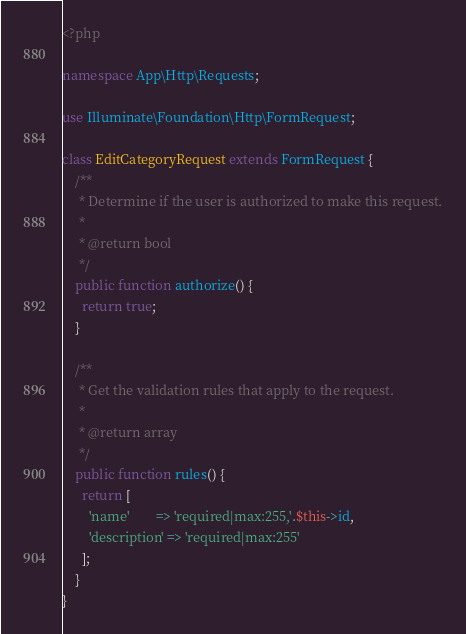Convert code to text. <code><loc_0><loc_0><loc_500><loc_500><_PHP_><?php

namespace App\Http\Requests;

use Illuminate\Foundation\Http\FormRequest;

class EditCategoryRequest extends FormRequest {
    /**
     * Determine if the user is authorized to make this request.
     *
     * @return bool
     */
    public function authorize() {
      return true;
    }

    /**
     * Get the validation rules that apply to the request.
     *
     * @return array
     */
    public function rules() {
      return [
        'name'        => 'required|max:255,'.$this->id,
        'description' => 'required|max:255'
      ];
    }
}
</code> 